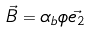<formula> <loc_0><loc_0><loc_500><loc_500>\vec { B } = \alpha _ { b } \phi \vec { e _ { 2 } }</formula> 